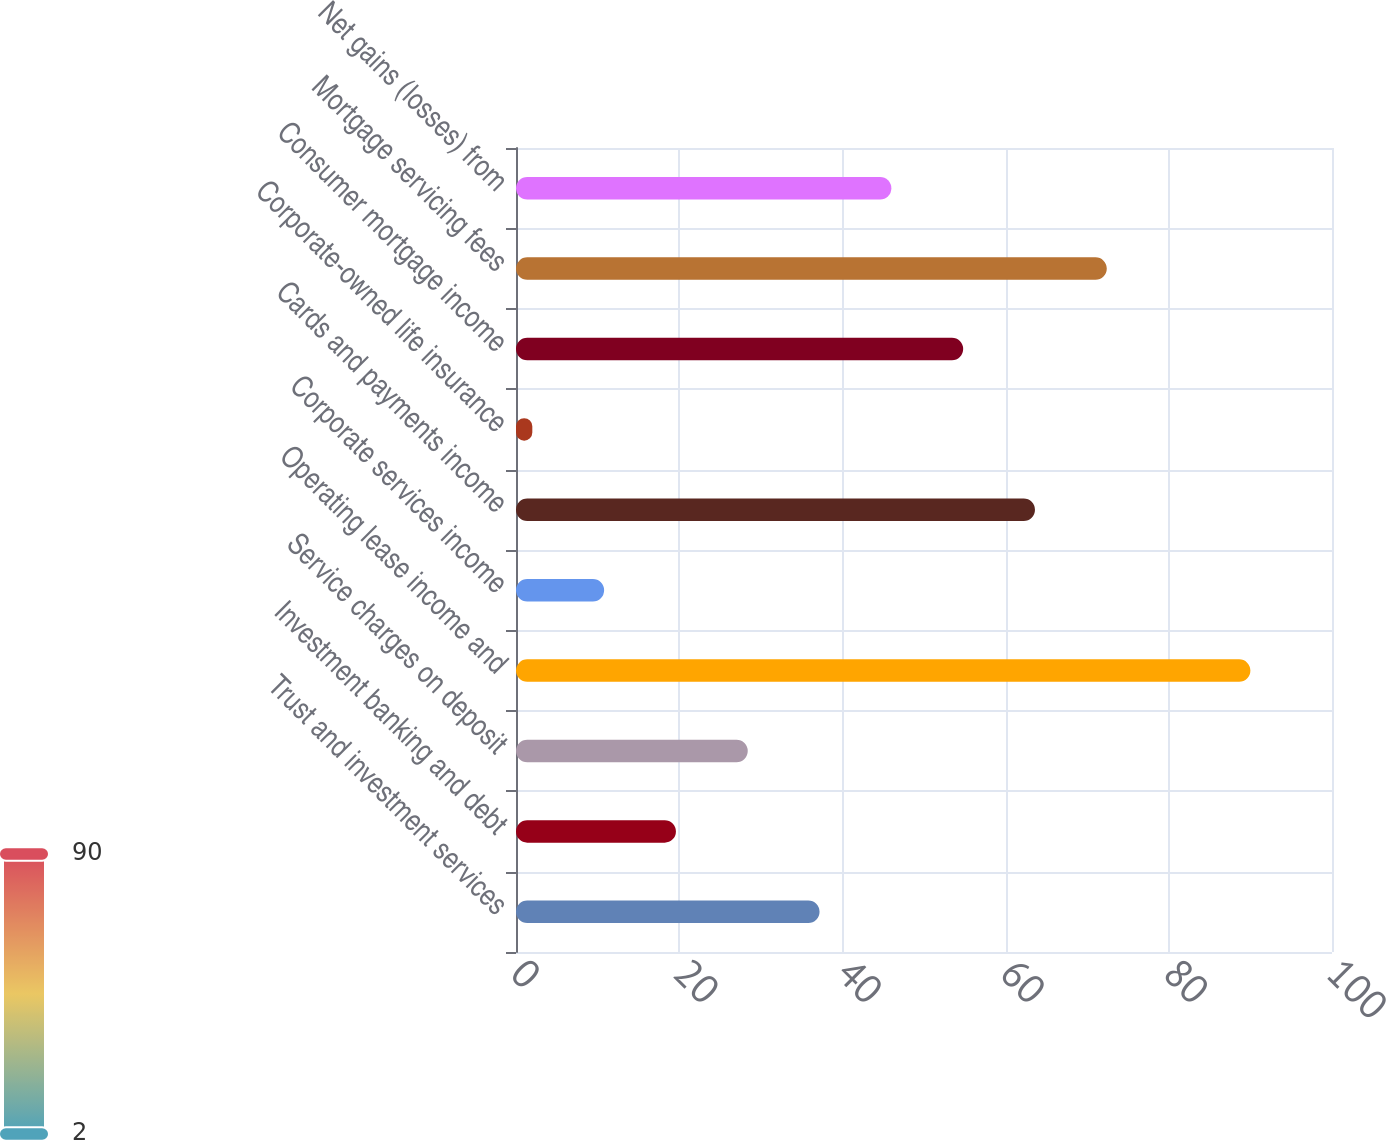<chart> <loc_0><loc_0><loc_500><loc_500><bar_chart><fcel>Trust and investment services<fcel>Investment banking and debt<fcel>Service charges on deposit<fcel>Operating lease income and<fcel>Corporate services income<fcel>Cards and payments income<fcel>Corporate-owned life insurance<fcel>Consumer mortgage income<fcel>Mortgage servicing fees<fcel>Net gains (losses) from<nl><fcel>37.2<fcel>19.6<fcel>28.4<fcel>90<fcel>10.8<fcel>63.6<fcel>2<fcel>54.8<fcel>72.4<fcel>46<nl></chart> 